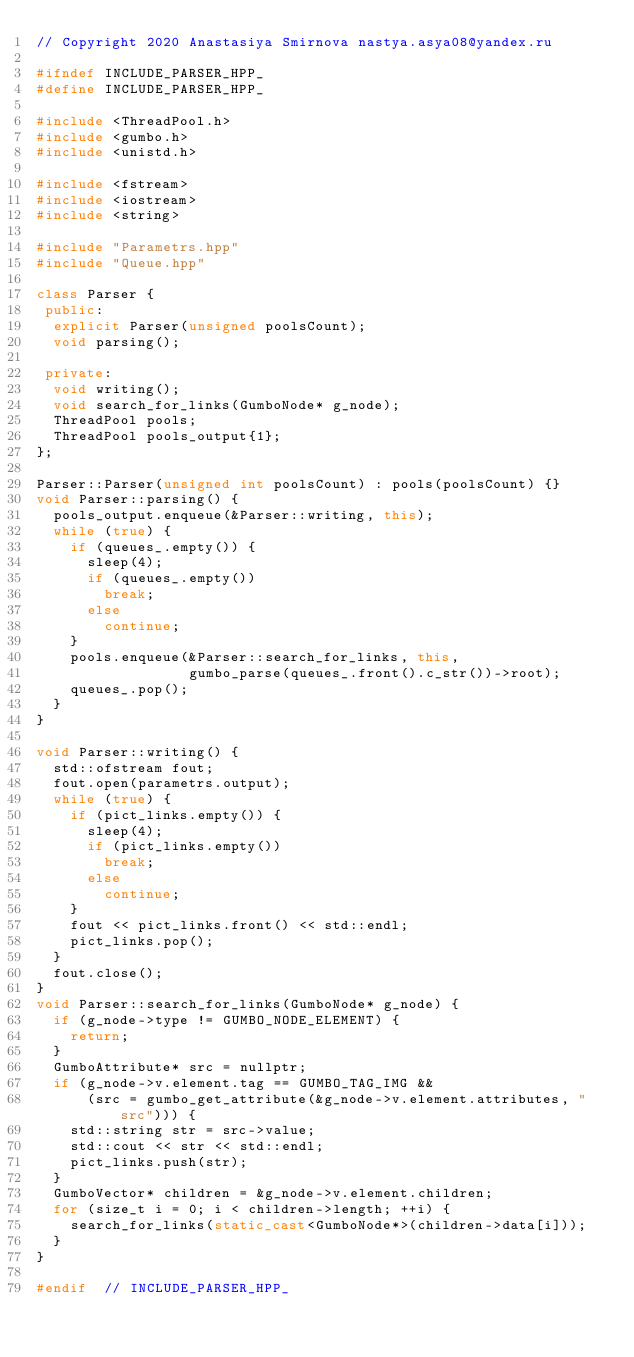Convert code to text. <code><loc_0><loc_0><loc_500><loc_500><_C++_>// Copyright 2020 Anastasiya Smirnova nastya.asya08@yandex.ru

#ifndef INCLUDE_PARSER_HPP_
#define INCLUDE_PARSER_HPP_

#include <ThreadPool.h>
#include <gumbo.h>
#include <unistd.h>

#include <fstream>
#include <iostream>
#include <string>

#include "Parametrs.hpp"
#include "Queue.hpp"

class Parser {
 public:
  explicit Parser(unsigned poolsCount);
  void parsing();

 private:
  void writing();
  void search_for_links(GumboNode* g_node);
  ThreadPool pools;
  ThreadPool pools_output{1};
};

Parser::Parser(unsigned int poolsCount) : pools(poolsCount) {}
void Parser::parsing() {
  pools_output.enqueue(&Parser::writing, this);
  while (true) {
    if (queues_.empty()) {
      sleep(4);
      if (queues_.empty())
        break;
      else
        continue;
    }
    pools.enqueue(&Parser::search_for_links, this,
                  gumbo_parse(queues_.front().c_str())->root);
    queues_.pop();
  }
}

void Parser::writing() {
  std::ofstream fout;
  fout.open(parametrs.output);
  while (true) {
    if (pict_links.empty()) {
      sleep(4);
      if (pict_links.empty())
        break;
      else
        continue;
    }
    fout << pict_links.front() << std::endl;
    pict_links.pop();
  }
  fout.close();
}
void Parser::search_for_links(GumboNode* g_node) {
  if (g_node->type != GUMBO_NODE_ELEMENT) {
    return;
  }
  GumboAttribute* src = nullptr;
  if (g_node->v.element.tag == GUMBO_TAG_IMG &&
      (src = gumbo_get_attribute(&g_node->v.element.attributes, "src"))) {
    std::string str = src->value;
    std::cout << str << std::endl;
    pict_links.push(str);
  }
  GumboVector* children = &g_node->v.element.children;
  for (size_t i = 0; i < children->length; ++i) {
    search_for_links(static_cast<GumboNode*>(children->data[i]));
  }
}

#endif  // INCLUDE_PARSER_HPP_
</code> 